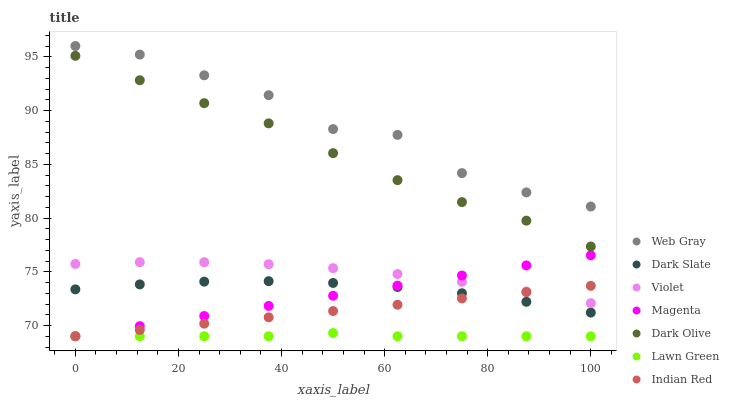Does Lawn Green have the minimum area under the curve?
Answer yes or no. Yes. Does Web Gray have the maximum area under the curve?
Answer yes or no. Yes. Does Dark Olive have the minimum area under the curve?
Answer yes or no. No. Does Dark Olive have the maximum area under the curve?
Answer yes or no. No. Is Indian Red the smoothest?
Answer yes or no. Yes. Is Web Gray the roughest?
Answer yes or no. Yes. Is Dark Olive the smoothest?
Answer yes or no. No. Is Dark Olive the roughest?
Answer yes or no. No. Does Lawn Green have the lowest value?
Answer yes or no. Yes. Does Dark Olive have the lowest value?
Answer yes or no. No. Does Web Gray have the highest value?
Answer yes or no. Yes. Does Dark Olive have the highest value?
Answer yes or no. No. Is Violet less than Web Gray?
Answer yes or no. Yes. Is Violet greater than Lawn Green?
Answer yes or no. Yes. Does Indian Red intersect Violet?
Answer yes or no. Yes. Is Indian Red less than Violet?
Answer yes or no. No. Is Indian Red greater than Violet?
Answer yes or no. No. Does Violet intersect Web Gray?
Answer yes or no. No. 